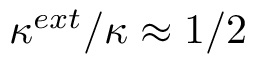Convert formula to latex. <formula><loc_0><loc_0><loc_500><loc_500>\kappa ^ { e x t } / \kappa \approx 1 / 2</formula> 